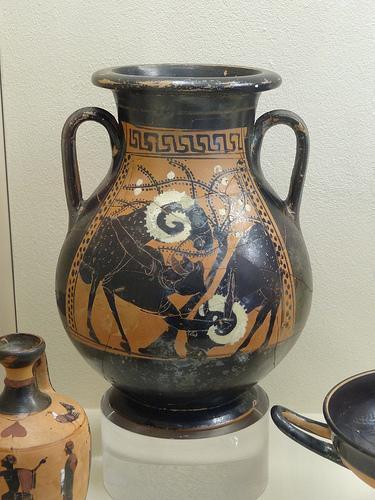How many people are breaking the jar?
Give a very brief answer. 0. 